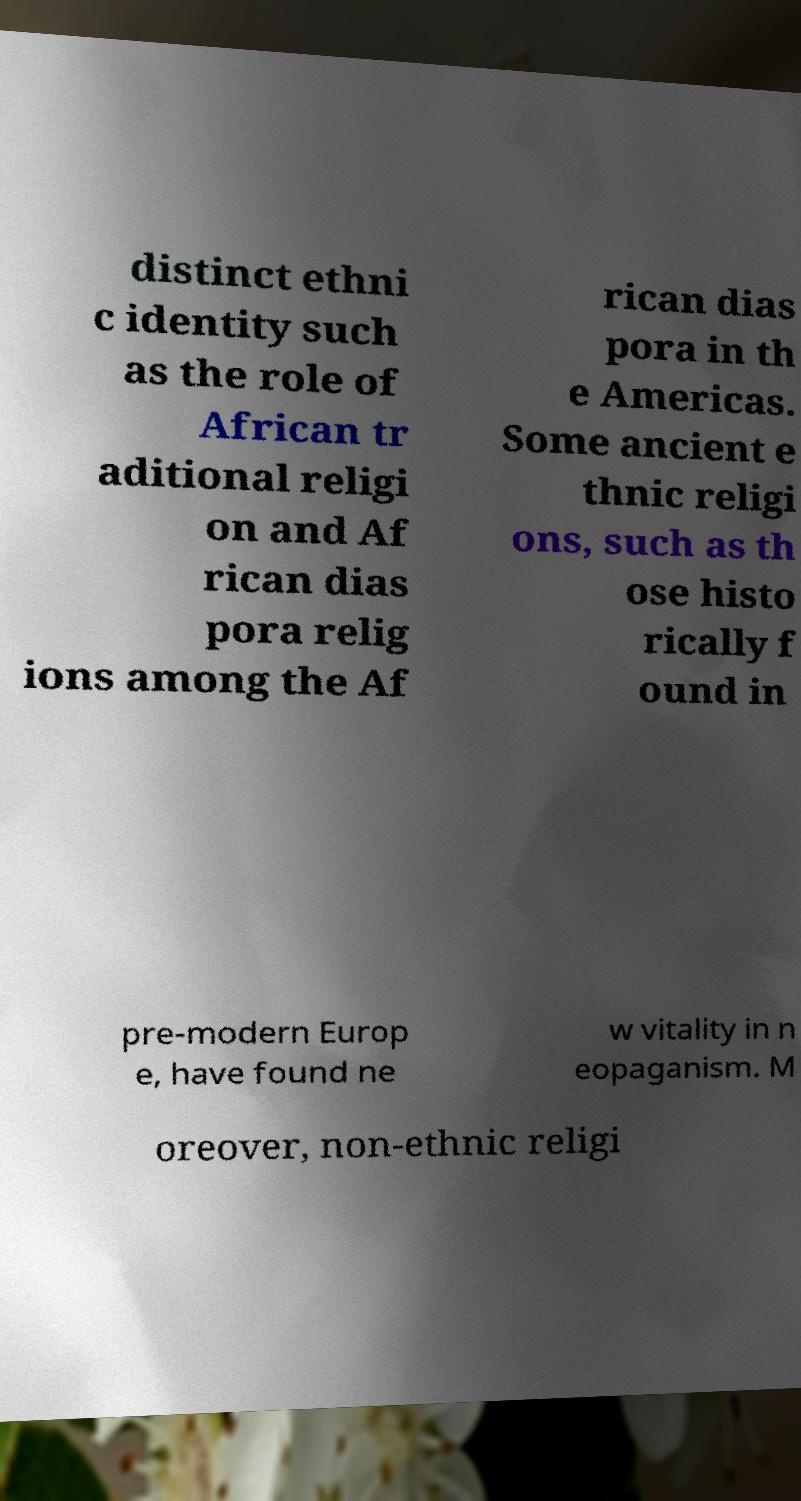Can you read and provide the text displayed in the image?This photo seems to have some interesting text. Can you extract and type it out for me? distinct ethni c identity such as the role of African tr aditional religi on and Af rican dias pora relig ions among the Af rican dias pora in th e Americas. Some ancient e thnic religi ons, such as th ose histo rically f ound in pre-modern Europ e, have found ne w vitality in n eopaganism. M oreover, non-ethnic religi 